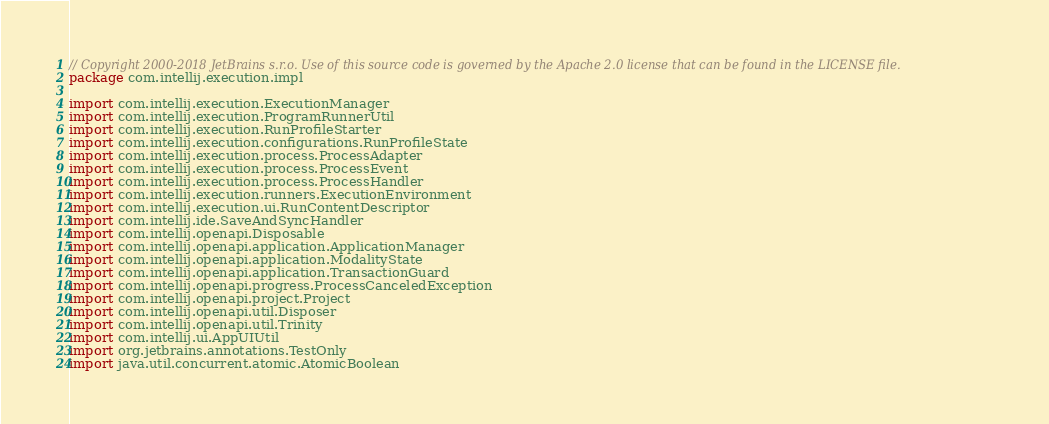Convert code to text. <code><loc_0><loc_0><loc_500><loc_500><_Kotlin_>// Copyright 2000-2018 JetBrains s.r.o. Use of this source code is governed by the Apache 2.0 license that can be found in the LICENSE file.
package com.intellij.execution.impl

import com.intellij.execution.ExecutionManager
import com.intellij.execution.ProgramRunnerUtil
import com.intellij.execution.RunProfileStarter
import com.intellij.execution.configurations.RunProfileState
import com.intellij.execution.process.ProcessAdapter
import com.intellij.execution.process.ProcessEvent
import com.intellij.execution.process.ProcessHandler
import com.intellij.execution.runners.ExecutionEnvironment
import com.intellij.execution.ui.RunContentDescriptor
import com.intellij.ide.SaveAndSyncHandler
import com.intellij.openapi.Disposable
import com.intellij.openapi.application.ApplicationManager
import com.intellij.openapi.application.ModalityState
import com.intellij.openapi.application.TransactionGuard
import com.intellij.openapi.progress.ProcessCanceledException
import com.intellij.openapi.project.Project
import com.intellij.openapi.util.Disposer
import com.intellij.openapi.util.Trinity
import com.intellij.ui.AppUIUtil
import org.jetbrains.annotations.TestOnly
import java.util.concurrent.atomic.AtomicBoolean
</code> 